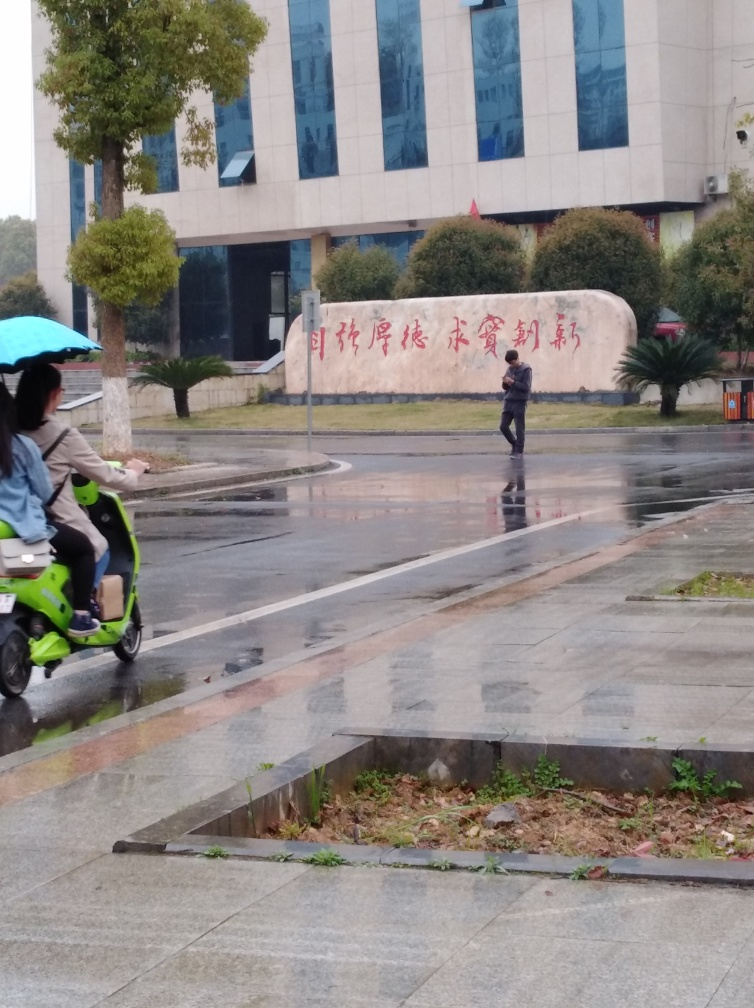What is the overall clarity of the image?
A. blurry
B. poor
C. decent
D. excellent The overall clarity of the image can be considered decent (Option C). The details like the reflections on the wet surface, the architectural lines of the building, and the writing on the wall are visible. However, there is some blurriness present, likely due to camera motion or unfavorable weather conditions, that prevents the image from being classified as excellent. 